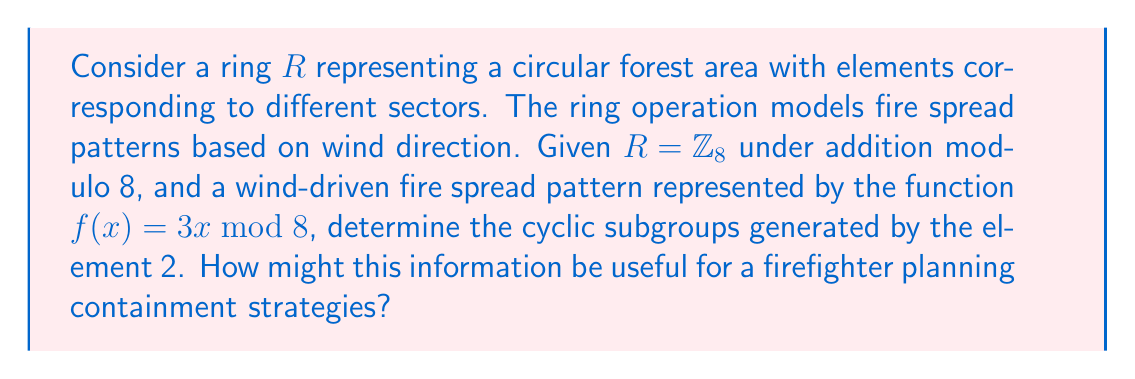Provide a solution to this math problem. To solve this problem, we need to follow these steps:

1) First, let's generate the cyclic subgroup of 2 under the given function $f(x) = 3x \mod 8$:

   $f(2) = 3 \cdot 2 \mod 8 = 6$
   $f(6) = 3 \cdot 6 \mod 8 = 2$

   We see that the cycle repeats after two applications of $f$. Therefore, the cyclic subgroup generated by 2 is $\{2, 6\}$.

2) In the context of fire spread patterns:
   - The element 2 represents a specific sector in the circular forest area.
   - The function $f(x) = 3x \mod 8$ models how the fire spreads from one sector to another based on wind direction.
   - The cyclic subgroup $\{2, 6\}$ shows that the fire will alternate between sectors 2 and 6 if left unchecked.

3) For a firefighter, this information is valuable for several reasons:
   a) It identifies the sectors that are at highest risk (2 and 6).
   b) It shows that the fire has a predictable pattern, alternating between these two sectors.
   c) This pattern suggests that focusing containment efforts on the areas between sectors 2 and 6 could be an effective strategy to break the cycle and prevent further spread.
   d) The firefighter can allocate resources more efficiently, concentrating on these critical areas rather than spreading resources evenly around the entire perimeter.

4) The fact that the cyclic subgroup has only two elements also indicates that the fire's spread is somewhat limited in this model. This could inform the overall urgency and scale of the response needed.
Answer: The cyclic subgroup generated by 2 is $\{2, 6\}$. This information allows a firefighter to identify high-risk sectors, predict the fire's alternating pattern between these sectors, and strategically focus containment efforts to break the cycle of fire spread. 